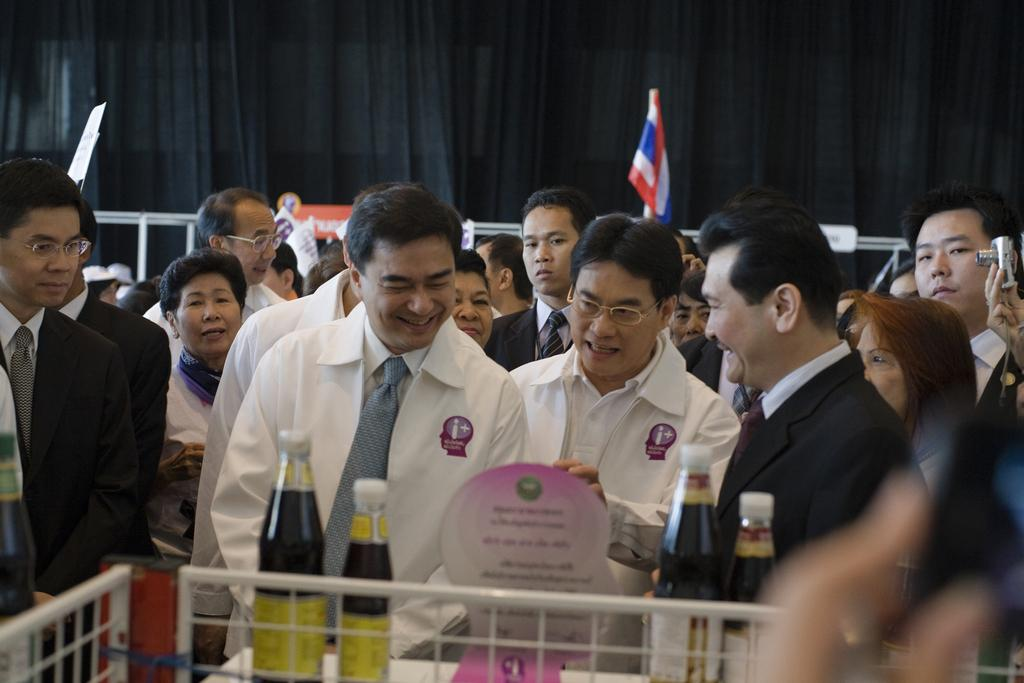What is happening in the image? There is a group of people standing in the image. What can be seen in the hands of some people in the image? There are bottles visible in the image. What other objects can be seen in the image besides the people and bottles? There are other objects present in the image. What can be seen in the background of the image? There are black color curtains and a flag in the background of the image. What type of list is being used by the people in the image? There is no list present in the image; it features a group of people standing with bottles and other objects. Can you see any dolls in the image? There are no dolls present in the image. 